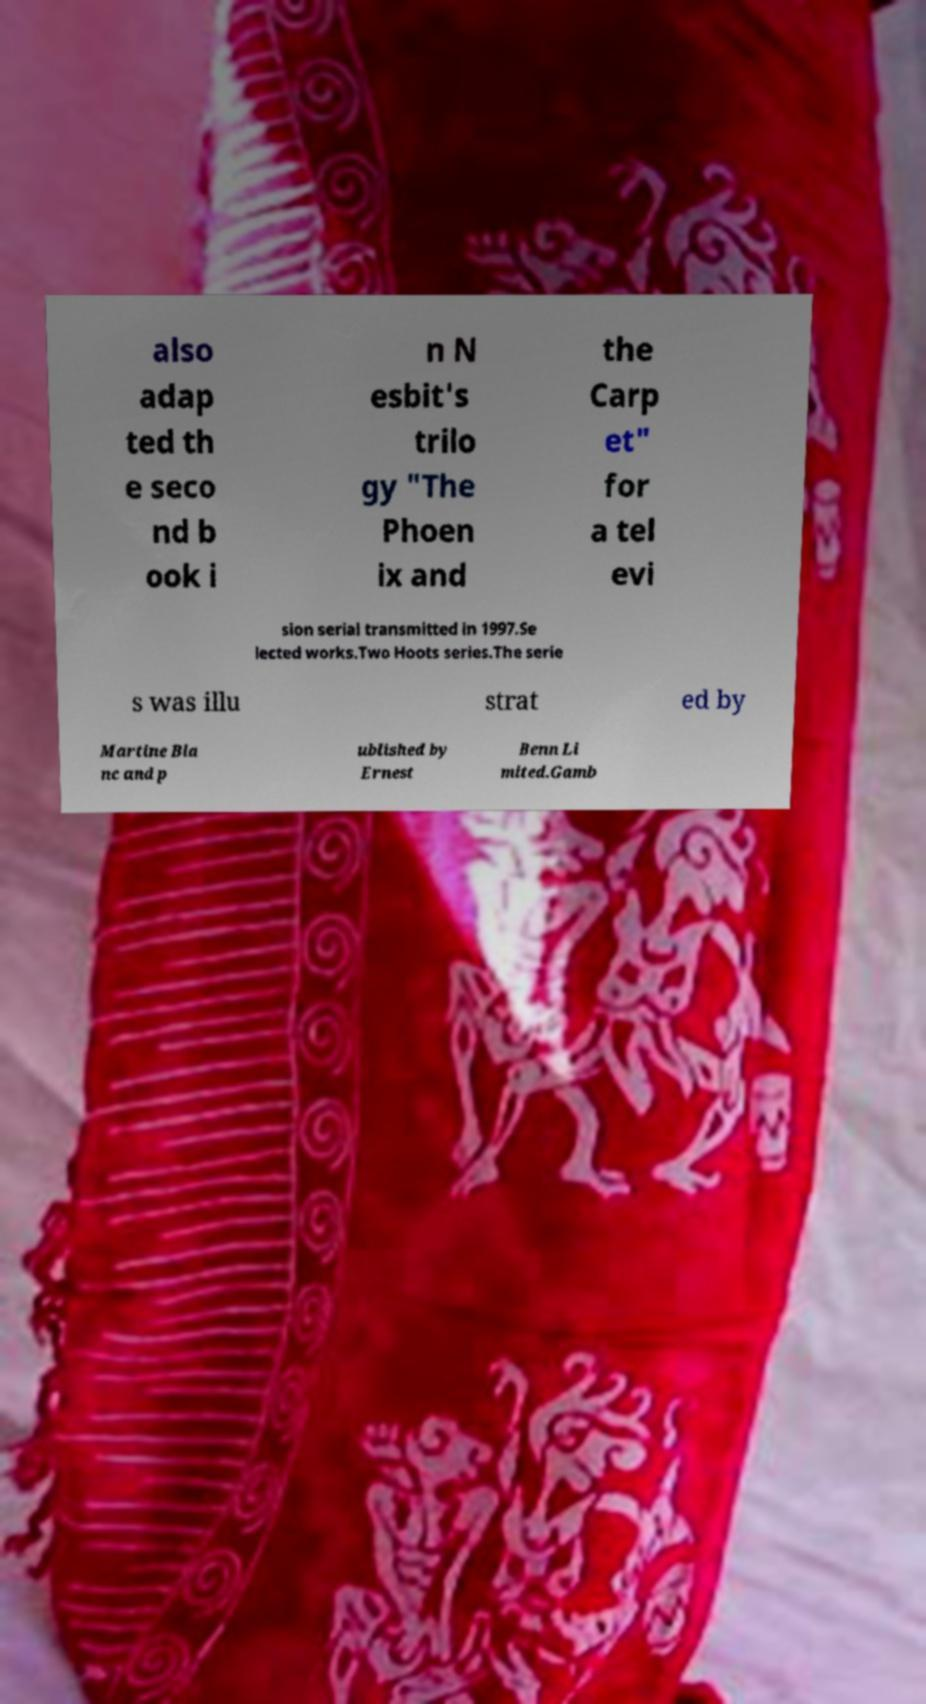Can you accurately transcribe the text from the provided image for me? also adap ted th e seco nd b ook i n N esbit's trilo gy "The Phoen ix and the Carp et" for a tel evi sion serial transmitted in 1997.Se lected works.Two Hoots series.The serie s was illu strat ed by Martine Bla nc and p ublished by Ernest Benn Li mited.Gamb 